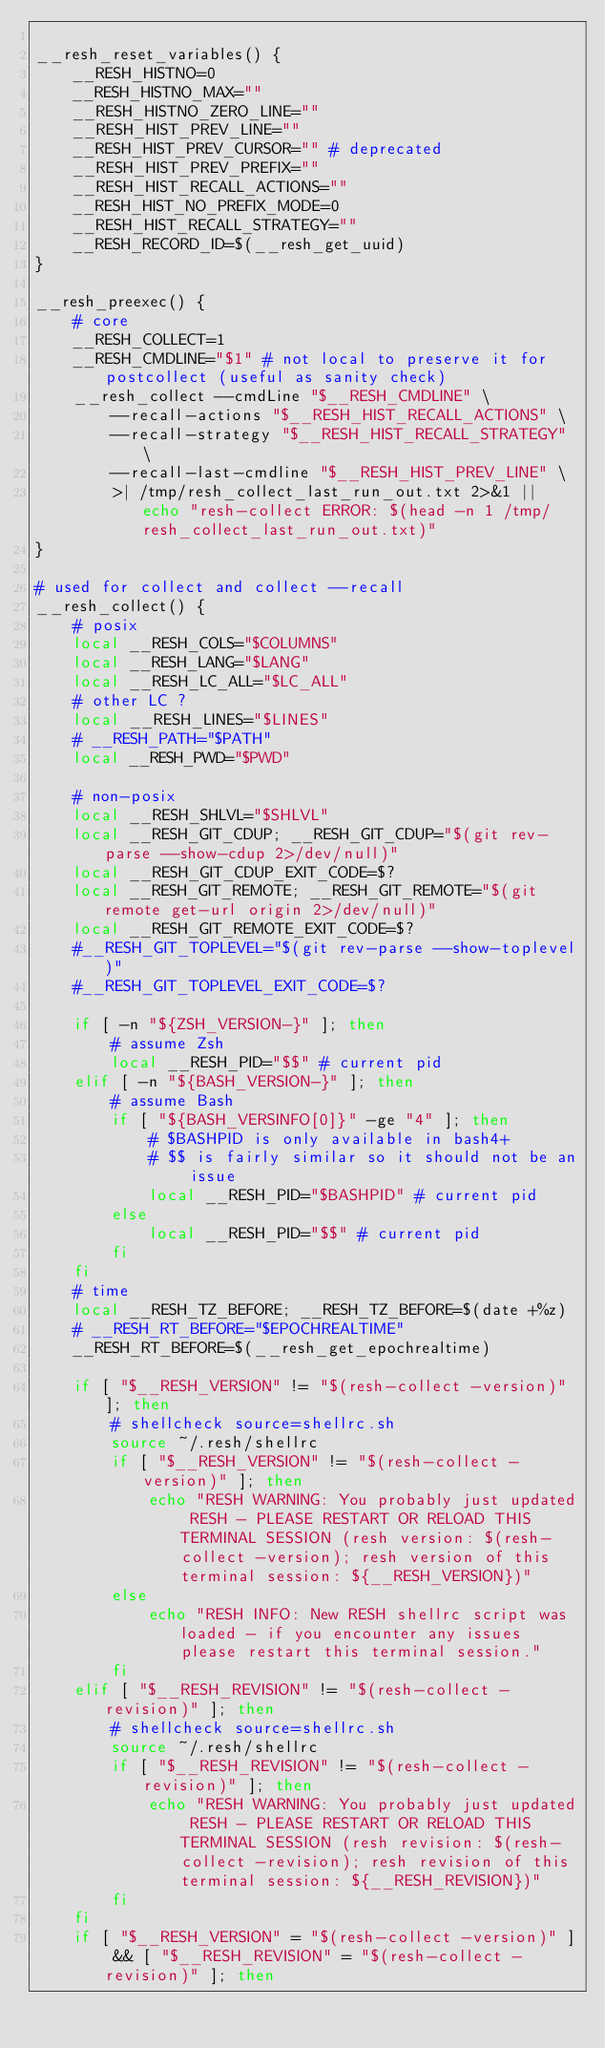<code> <loc_0><loc_0><loc_500><loc_500><_Bash_>
__resh_reset_variables() {
    __RESH_HISTNO=0
    __RESH_HISTNO_MAX=""
    __RESH_HISTNO_ZERO_LINE=""
    __RESH_HIST_PREV_LINE="" 
    __RESH_HIST_PREV_CURSOR="" # deprecated
    __RESH_HIST_PREV_PREFIX=""
    __RESH_HIST_RECALL_ACTIONS=""
    __RESH_HIST_NO_PREFIX_MODE=0
    __RESH_HIST_RECALL_STRATEGY=""
    __RESH_RECORD_ID=$(__resh_get_uuid)
}

__resh_preexec() {
    # core
    __RESH_COLLECT=1
    __RESH_CMDLINE="$1" # not local to preserve it for postcollect (useful as sanity check)
    __resh_collect --cmdLine "$__RESH_CMDLINE" \
        --recall-actions "$__RESH_HIST_RECALL_ACTIONS" \
        --recall-strategy "$__RESH_HIST_RECALL_STRATEGY" \
        --recall-last-cmdline "$__RESH_HIST_PREV_LINE" \
        >| /tmp/resh_collect_last_run_out.txt 2>&1 || echo "resh-collect ERROR: $(head -n 1 /tmp/resh_collect_last_run_out.txt)"
}

# used for collect and collect --recall
__resh_collect() {
    # posix
    local __RESH_COLS="$COLUMNS"
    local __RESH_LANG="$LANG"
    local __RESH_LC_ALL="$LC_ALL"
    # other LC ?
    local __RESH_LINES="$LINES"
    # __RESH_PATH="$PATH"
    local __RESH_PWD="$PWD"
    
    # non-posix
    local __RESH_SHLVL="$SHLVL"
    local __RESH_GIT_CDUP; __RESH_GIT_CDUP="$(git rev-parse --show-cdup 2>/dev/null)"
    local __RESH_GIT_CDUP_EXIT_CODE=$?
    local __RESH_GIT_REMOTE; __RESH_GIT_REMOTE="$(git remote get-url origin 2>/dev/null)"
    local __RESH_GIT_REMOTE_EXIT_CODE=$?
    #__RESH_GIT_TOPLEVEL="$(git rev-parse --show-toplevel)"
    #__RESH_GIT_TOPLEVEL_EXIT_CODE=$?

    if [ -n "${ZSH_VERSION-}" ]; then
        # assume Zsh
        local __RESH_PID="$$" # current pid
    elif [ -n "${BASH_VERSION-}" ]; then
        # assume Bash
        if [ "${BASH_VERSINFO[0]}" -ge "4" ]; then
            # $BASHPID is only available in bash4+
            # $$ is fairly similar so it should not be an issue
            local __RESH_PID="$BASHPID" # current pid
        else
            local __RESH_PID="$$" # current pid
        fi
    fi
    # time
    local __RESH_TZ_BEFORE; __RESH_TZ_BEFORE=$(date +%z)
    # __RESH_RT_BEFORE="$EPOCHREALTIME"
    __RESH_RT_BEFORE=$(__resh_get_epochrealtime)

    if [ "$__RESH_VERSION" != "$(resh-collect -version)" ]; then
        # shellcheck source=shellrc.sh
        source ~/.resh/shellrc 
        if [ "$__RESH_VERSION" != "$(resh-collect -version)" ]; then
            echo "RESH WARNING: You probably just updated RESH - PLEASE RESTART OR RELOAD THIS TERMINAL SESSION (resh version: $(resh-collect -version); resh version of this terminal session: ${__RESH_VERSION})"
        else
            echo "RESH INFO: New RESH shellrc script was loaded - if you encounter any issues please restart this terminal session."
        fi
    elif [ "$__RESH_REVISION" != "$(resh-collect -revision)" ]; then
        # shellcheck source=shellrc.sh
        source ~/.resh/shellrc 
        if [ "$__RESH_REVISION" != "$(resh-collect -revision)" ]; then
            echo "RESH WARNING: You probably just updated RESH - PLEASE RESTART OR RELOAD THIS TERMINAL SESSION (resh revision: $(resh-collect -revision); resh revision of this terminal session: ${__RESH_REVISION})"
        fi
    fi
    if [ "$__RESH_VERSION" = "$(resh-collect -version)" ] && [ "$__RESH_REVISION" = "$(resh-collect -revision)" ]; then</code> 